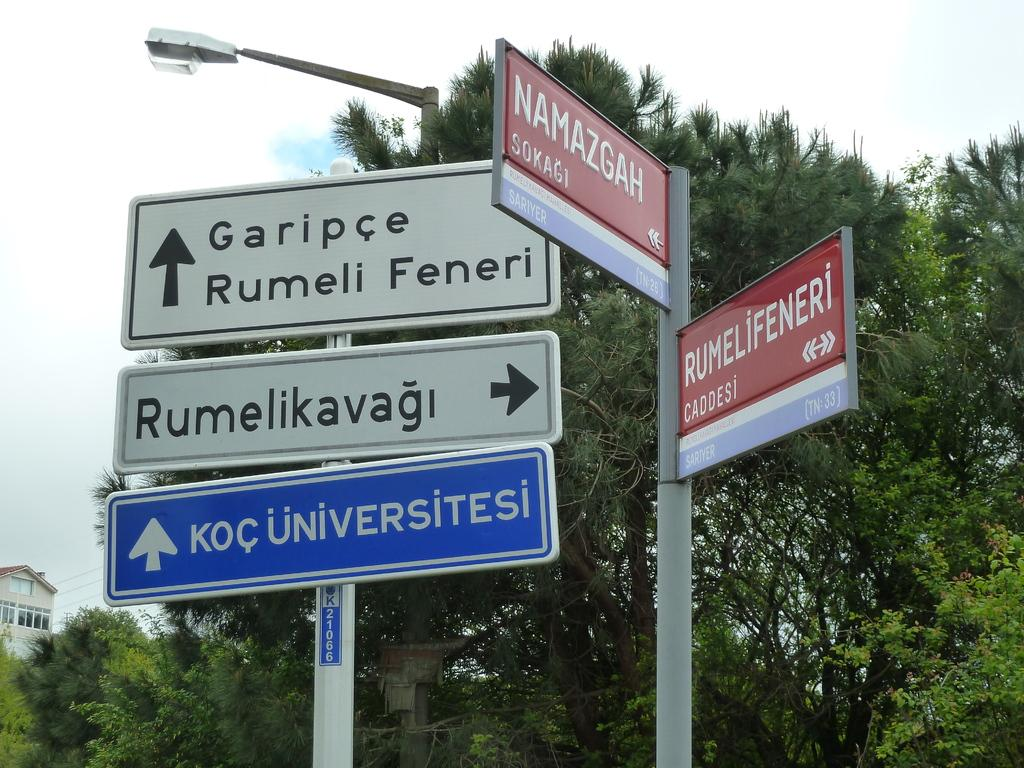Provide a one-sentence caption for the provided image. The poles are at the intersection of Namazgah and Rumelifeneri. 